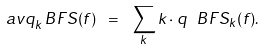<formula> <loc_0><loc_0><loc_500><loc_500>\ a v { q _ { k } ^ { \ } B F S } ( f ) \ = \ \sum _ { k } k \cdot q ^ { \ } B F S _ { k } ( f ) .</formula> 